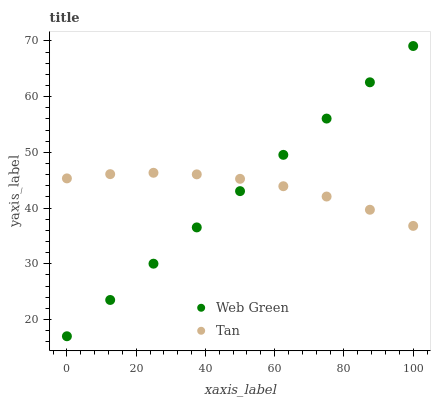Does Web Green have the minimum area under the curve?
Answer yes or no. Yes. Does Tan have the maximum area under the curve?
Answer yes or no. Yes. Does Web Green have the maximum area under the curve?
Answer yes or no. No. Is Web Green the smoothest?
Answer yes or no. Yes. Is Tan the roughest?
Answer yes or no. Yes. Is Web Green the roughest?
Answer yes or no. No. Does Web Green have the lowest value?
Answer yes or no. Yes. Does Web Green have the highest value?
Answer yes or no. Yes. Does Tan intersect Web Green?
Answer yes or no. Yes. Is Tan less than Web Green?
Answer yes or no. No. Is Tan greater than Web Green?
Answer yes or no. No. 